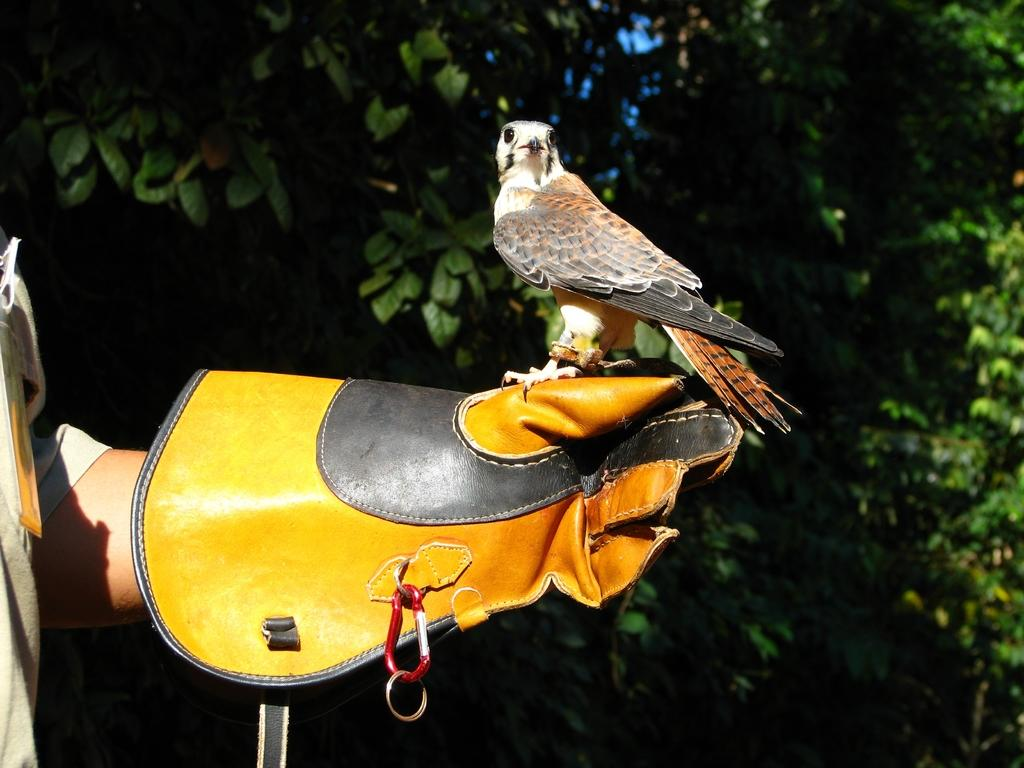What is on the hand of the person in the image? There is a glove on the hand of the person in the image. What is on the glove? There is a bird on the glove. What can be seen in the background of the image? There are trees in the background of the image. What subject is the person teaching in the image? There is no indication in the image that the person is teaching a subject. How does the bird feel about being on the glove? The image does not provide information about the bird's feelings or emotions. 